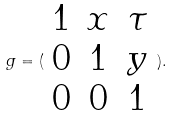<formula> <loc_0><loc_0><loc_500><loc_500>g = ( \begin{array} { c c c } 1 & x & \tau \\ 0 & 1 & y \\ 0 & 0 & 1 \end{array} ) .</formula> 